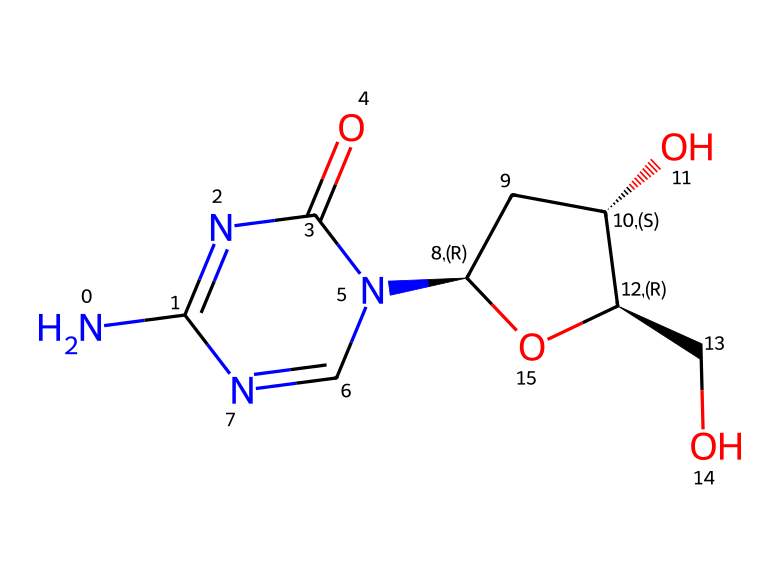What is the molecular formula of this compound? By analyzing the SMILES notation, we identify and count the atoms of each element: 7 Carbon (C), 12 Hydrogen (H), 4 Nitrogen (N), and 4 Oxygen (O). Therefore, the molecular formula is constructed by combining these counts into a standardized format.
Answer: C7H12N4O4 How many ring structures are present in this chemical? Examining the SMILES representation, we observe that there is a cyclized structure that includes two rings indicated by the '1' notation and another loop formed in the transition to another carbon. By tracing through the SMILES, we can confirm there are two distinct ring structures present.
Answer: 2 What type of functional groups are present? Reviewing the structure through its SMILES representation, we identify groups that are characteristic of medicinal compounds, such as amines (–NH), alcohols (–OH), and carbonyls (–C=O). Recognizing these chemical landmarks allows us to characterize the functional groups effectively.
Answer: amine, alcohol, carbonyl How many stereocenters are found in this compound? The presence of stereocenters can be evaluated from the structure based on the presence of chiral centers identified in the SMILES notation with the '@' symbols. In this compound, two stereocenters are indicated at the specified carbon atoms.
Answer: 2 What is the primary role of this compound in therapeutic applications? Considering the context of DNA methylation inhibitors, this compound's structure is designed to interfere with the enzyme activity responsible for DNA methylation, thus modulating gene expression. Insights into how its specific composition impacts biological interaction provide an understanding of its therapeutic mechanism.
Answer: DNA methylation inhibition 